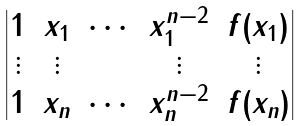Convert formula to latex. <formula><loc_0><loc_0><loc_500><loc_500>\begin{vmatrix} 1 & x _ { 1 } & \cdots & x _ { 1 } ^ { n - 2 } & f ( x _ { 1 } ) \\ \vdots & \vdots & & \vdots & \vdots \\ 1 & x _ { n } & \cdots & x _ { n } ^ { n - 2 } & f ( x _ { n } ) \end{vmatrix}</formula> 